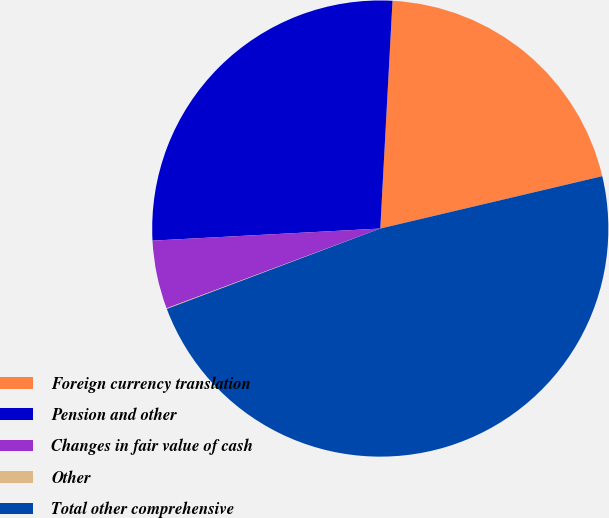Convert chart to OTSL. <chart><loc_0><loc_0><loc_500><loc_500><pie_chart><fcel>Foreign currency translation<fcel>Pension and other<fcel>Changes in fair value of cash<fcel>Other<fcel>Total other comprehensive<nl><fcel>20.46%<fcel>26.7%<fcel>4.84%<fcel>0.05%<fcel>47.96%<nl></chart> 